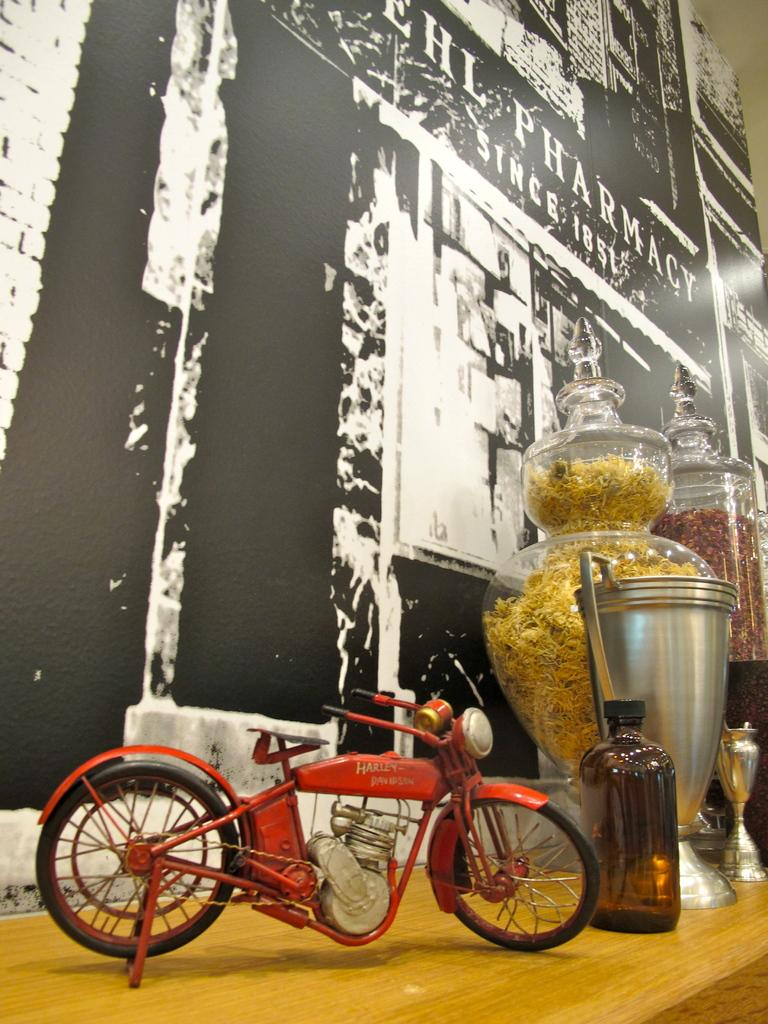What is the main piece of furniture in the image? There is a table in the image. What is placed on the table? There are jars on the table. What can be found inside the jars? There is a food item in the jars. What is an unexpected item found in the jars? There is a toy bike in the jars. What can be seen in the background of the image? There is a wall in the background of the image. What type of twig can be seen growing on the wall in the image? There is no twig visible on the wall in the image. What letter is written on the jars in the image? The jars in the image do not have any letters written on them. 